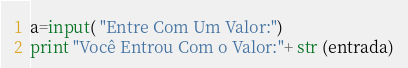Convert code to text. <code><loc_0><loc_0><loc_500><loc_500><_Python_>a=input( "Entre Com Um Valor:")
print "Você Entrou Com o Valor:"+ str (entrada)

</code> 